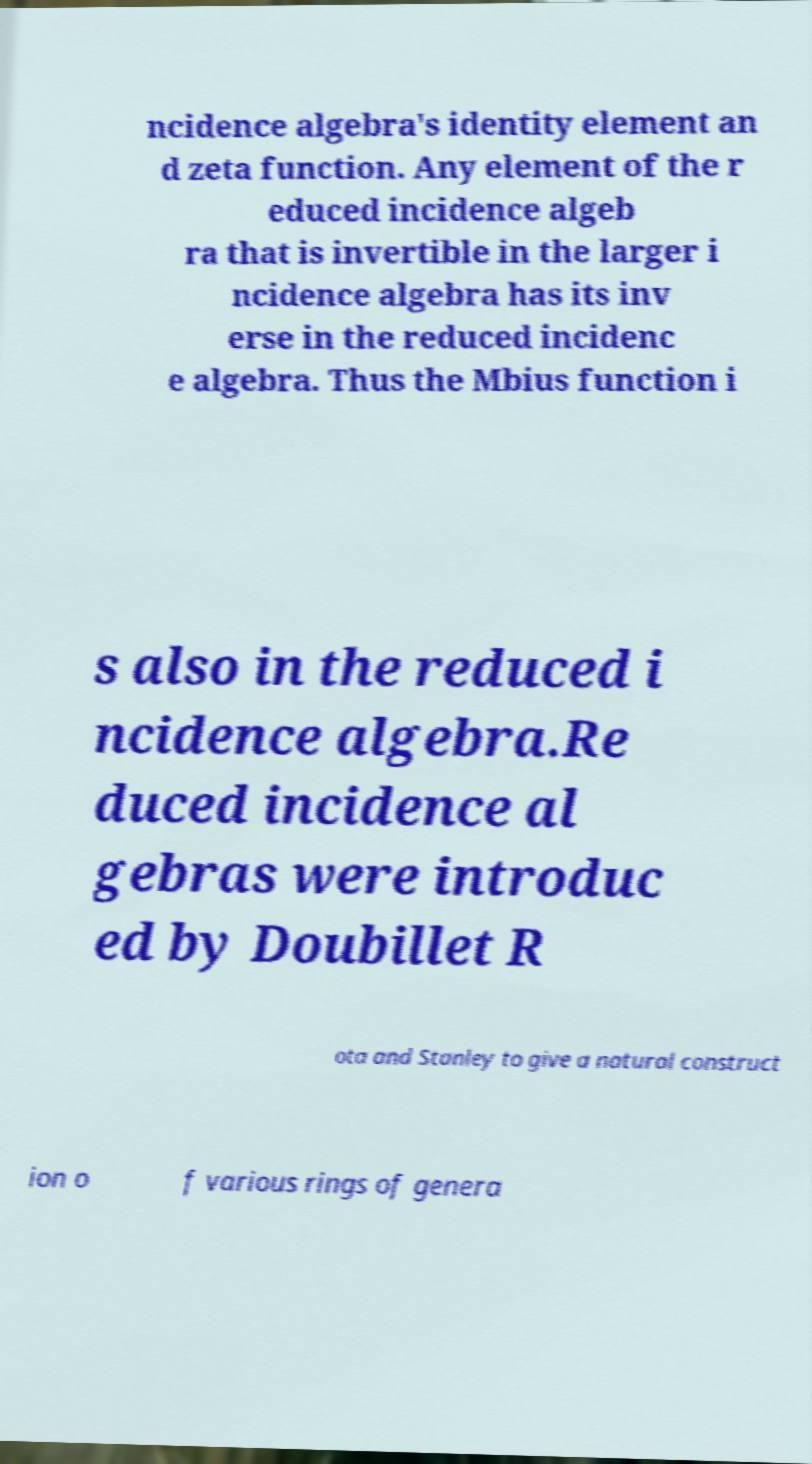What messages or text are displayed in this image? I need them in a readable, typed format. ncidence algebra's identity element an d zeta function. Any element of the r educed incidence algeb ra that is invertible in the larger i ncidence algebra has its inv erse in the reduced incidenc e algebra. Thus the Mbius function i s also in the reduced i ncidence algebra.Re duced incidence al gebras were introduc ed by Doubillet R ota and Stanley to give a natural construct ion o f various rings of genera 